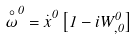Convert formula to latex. <formula><loc_0><loc_0><loc_500><loc_500>\overset { \circ } { \omega } ^ { 0 } = \overset { . } { x } ^ { 0 } \left [ 1 - i W _ { , 0 } ^ { 0 } \right ]</formula> 